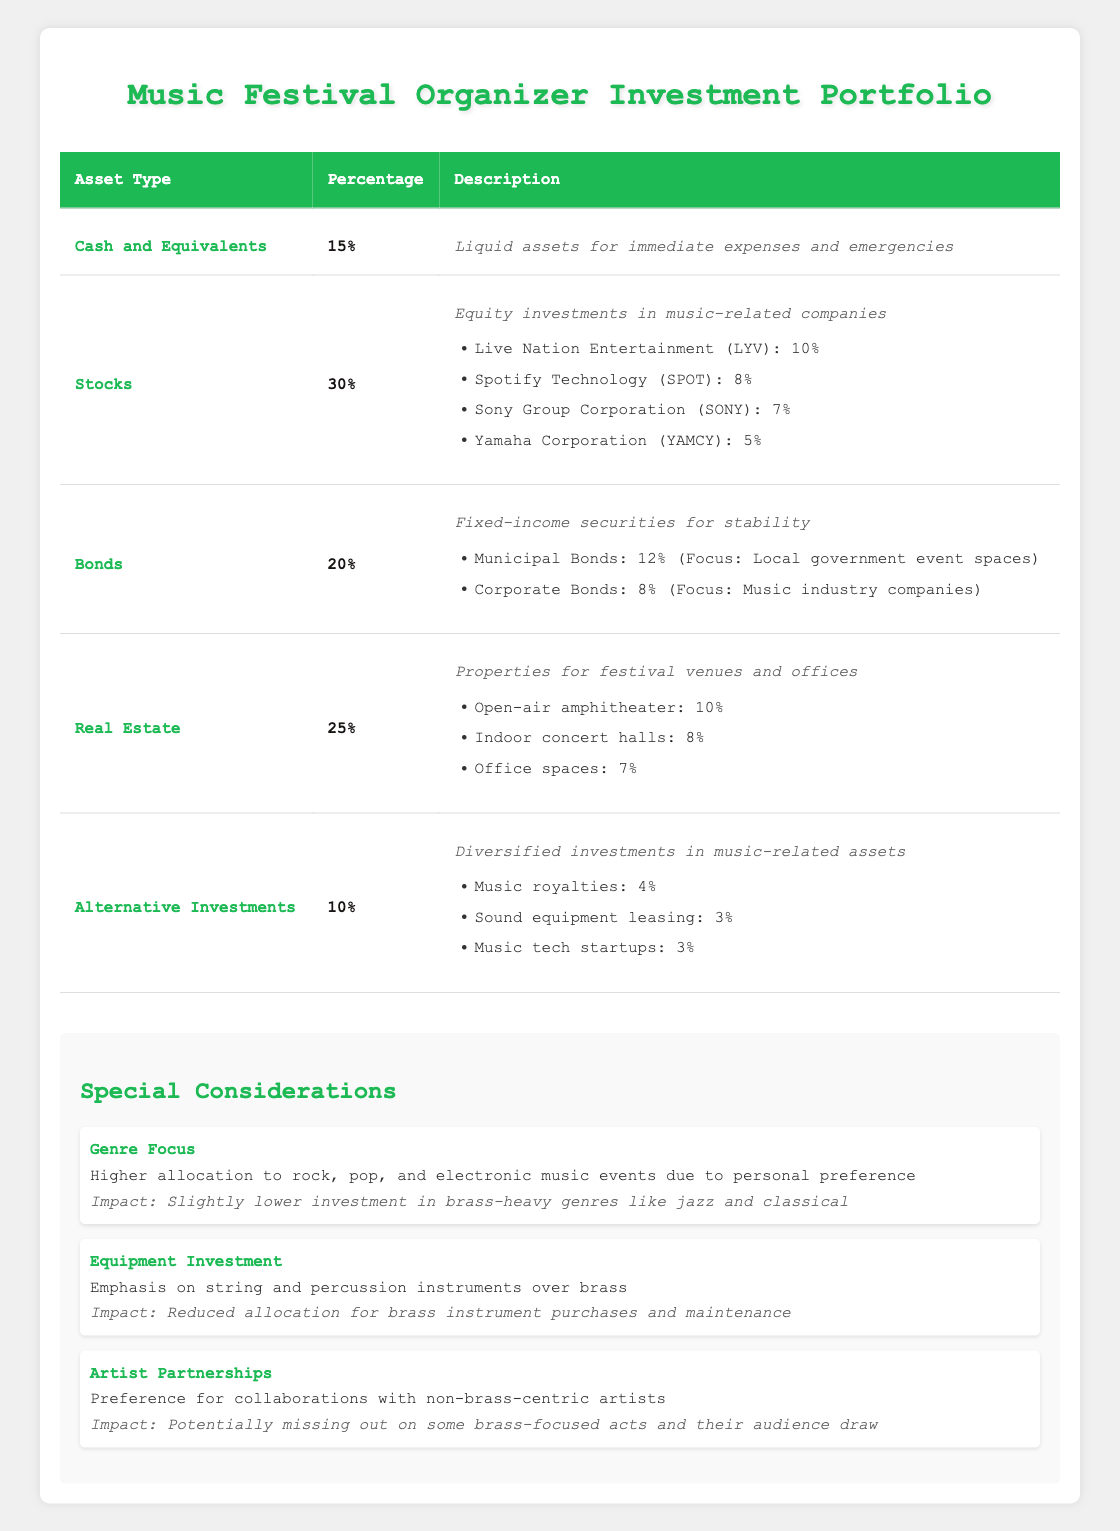What is the total percentage allocated to Stocks? The percentage allocated to Stocks is given directly in the table as 30%.
Answer: 30% What is the allocation for Live Nation Entertainment? The allocation for Live Nation Entertainment is listed in the holdings section under Stocks, which shows it as 10%.
Answer: 10% Are there any bonds allocated specifically for music industry companies? Yes, under the Bonds section, there is an allocation of 8% for Corporate Bonds focusing on music industry companies.
Answer: Yes What is the total percentage allocated to Real Estate and Bonds combined? The percentage for Real Estate is 25% and for Bonds is 20%. Adding these gives 25% + 20% = 45%.
Answer: 45% Is the investment in brass instruments prioritized over string and percussion investments? No, the description under Equipment Investment states there is an emphasis on string and percussion instruments over brass, indicating brass instruments are deprioritized.
Answer: No What percentage of the portfolio is allocated to Alternative Investments? The table indicates that the percentage for Alternative Investments is 10%.
Answer: 10% What is the average allocation percentage for holdings in the Bonds category? For Bonds, there are two holdings: Municipal Bonds at 12% and Corporate Bonds at 8%. The average is calculated as (12 + 8) / 2 = 10%.
Answer: 10% What is the total allocation for the different property types under Real Estate? The allocations are Open-air amphitheater at 10%, Indoor concert halls at 8%, and Office spaces at 7%. Summing these gives 10% + 8% + 7% = 25%.
Answer: 25% Does this portfolio have any cash and equivalents allocated? Yes, the Cash and Equivalents section shows an allocation of 15%.
Answer: Yes 